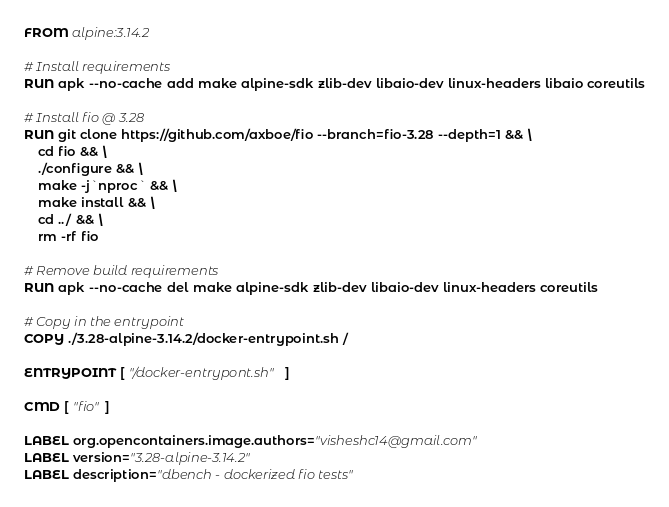Convert code to text. <code><loc_0><loc_0><loc_500><loc_500><_Dockerfile_>FROM alpine:3.14.2

# Install requirements
RUN apk --no-cache add make alpine-sdk zlib-dev libaio-dev linux-headers libaio coreutils

# Install fio @ 3.28
RUN git clone https://github.com/axboe/fio --branch=fio-3.28 --depth=1 && \
    cd fio && \
    ./configure && \
    make -j`nproc` && \
    make install && \
    cd ../ && \
    rm -rf fio

# Remove build requirements
RUN apk --no-cache del make alpine-sdk zlib-dev libaio-dev linux-headers coreutils

# Copy in the entrypoint
COPY ./3.28-alpine-3.14.2/docker-entrypoint.sh /

ENTRYPOINT [ "/docker-entrypont.sh" ]

CMD [ "fio" ]

LABEL org.opencontainers.image.authors="visheshc14@gmail.com"
LABEL version="3.28-alpine-3.14.2"
LABEL description="dbench - dockerized fio tests"
</code> 